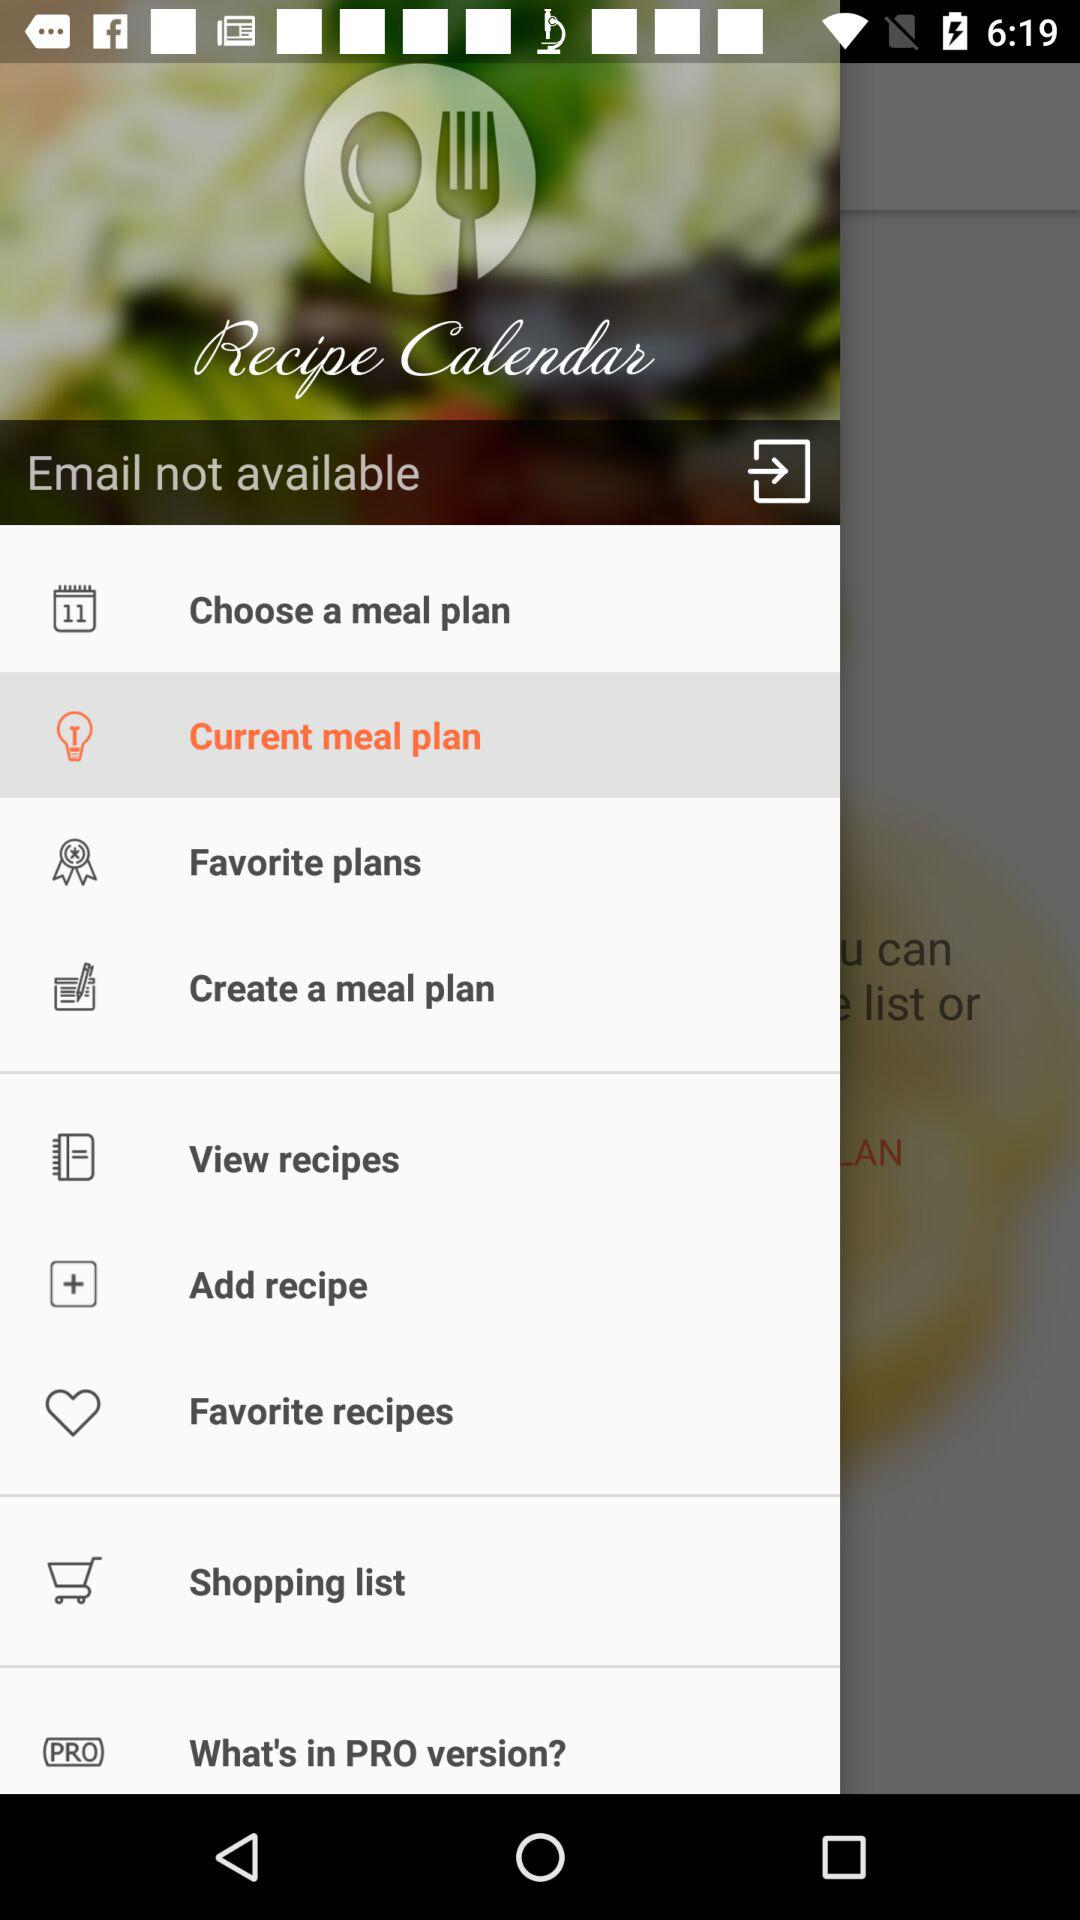Which item is selected? The selected item is "Current meal plan". 